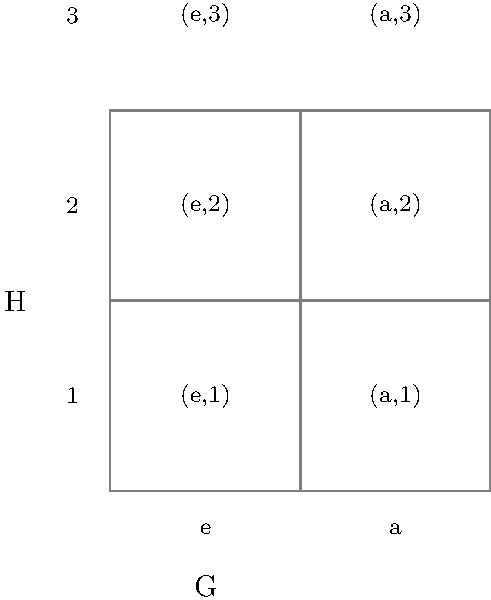Given the direct product of two groups $G \times H$ represented in the grid above, where $G = \{e, a\}$ and $H = \{1, 2, 3\}$, how many elements are in the resulting group $G \times H$? Additionally, what is the order of the element $(a,2)$ in $G \times H$, assuming $a^2 = e$ in $G$ and $2^3 = 1$ in $H$? To answer this question, let's break it down into steps:

1. Number of elements in $G \times H$:
   - Group $G$ has 2 elements: $\{e, a\}$
   - Group $H$ has 3 elements: $\{1, 2, 3\}$
   - The direct product $G \times H$ consists of all possible pairs $(g,h)$ where $g \in G$ and $h \in H$
   - The total number of elements in $G \times H$ is the product of the number of elements in $G$ and $H$
   - Therefore, $|G \times H| = |G| \cdot |H| = 2 \cdot 3 = 6$

2. Order of the element $(a,2)$ in $G \times H$:
   - The order of an element is the smallest positive integer $n$ such that $(a,2)^n = (e,1)$
   - We need to find the least common multiple (LCM) of the orders of $a$ in $G$ and $2$ in $H$
   - Given: $a^2 = e$ in $G$, so the order of $a$ is 2
   - Given: $2^3 = 1$ in $H$, so the order of $2$ is 3
   - LCM(2,3) = 6
   - Therefore, the order of $(a,2)$ in $G \times H$ is 6

The order of $(a,2)$ can be verified:
$(a,2)^1 = (a,2)$
$(a,2)^2 = (e,1)$
$(a,2)^3 = (a,2)$
$(a,2)^4 = (e,1)$
$(a,2)^5 = (a,2)$
$(a,2)^6 = (e,1)$

Thus, 6 is the smallest positive integer $n$ such that $(a,2)^n = (e,1)$.
Answer: 6 elements; order of $(a,2)$ is 6 